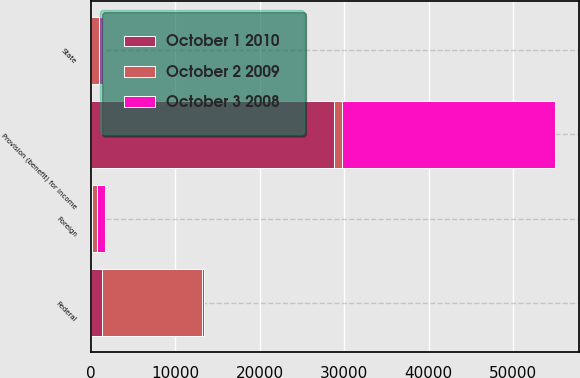Convert chart to OTSL. <chart><loc_0><loc_0><loc_500><loc_500><stacked_bar_chart><ecel><fcel>Federal<fcel>State<fcel>Foreign<fcel>Provision (benefit) for income<nl><fcel>October 2 2009<fcel>11855<fcel>946<fcel>684<fcel>946<nl><fcel>October 3 2008<fcel>251<fcel>413<fcel>966<fcel>25227<nl><fcel>October 1 2010<fcel>1310<fcel>72<fcel>94<fcel>28818<nl></chart> 